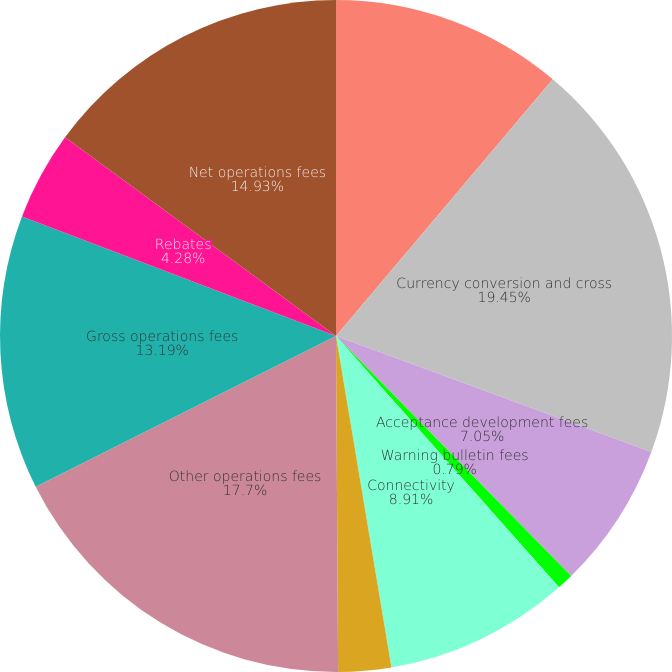Convert chart to OTSL. <chart><loc_0><loc_0><loc_500><loc_500><pie_chart><fcel>Authorization settlement and<fcel>Currency conversion and cross<fcel>Acceptance development fees<fcel>Warning bulletin fees<fcel>Connectivity<fcel>Consulting and research fees<fcel>Other operations fees<fcel>Gross operations fees<fcel>Rebates<fcel>Net operations fees<nl><fcel>11.16%<fcel>19.45%<fcel>7.05%<fcel>0.79%<fcel>8.91%<fcel>2.54%<fcel>17.7%<fcel>13.19%<fcel>4.28%<fcel>14.93%<nl></chart> 